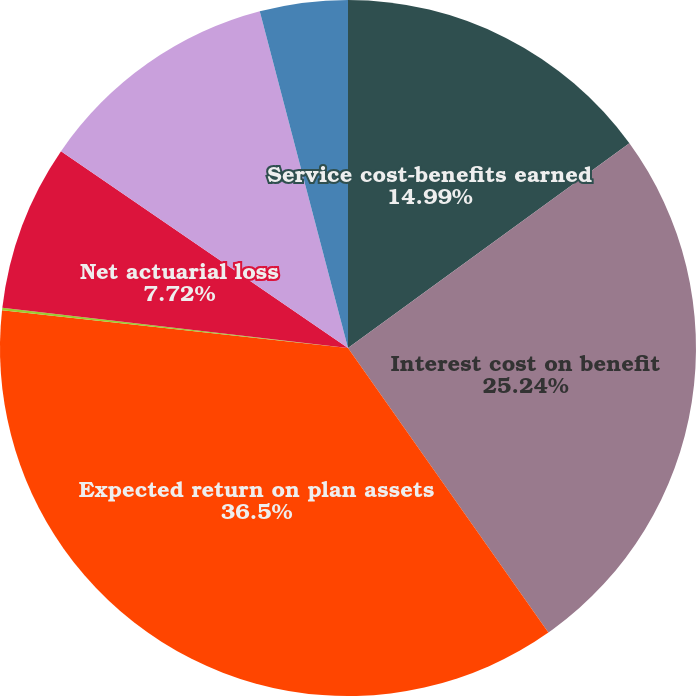Convert chart to OTSL. <chart><loc_0><loc_0><loc_500><loc_500><pie_chart><fcel>Service cost-benefits earned<fcel>Interest cost on benefit<fcel>Expected return on plan assets<fcel>Prior service cost (credit)<fcel>Net actuarial loss<fcel>Net periodic benefit cost<fcel>Portion of cost charged to<nl><fcel>14.99%<fcel>25.24%<fcel>36.49%<fcel>0.12%<fcel>7.72%<fcel>11.35%<fcel>4.08%<nl></chart> 